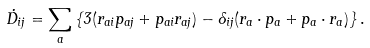Convert formula to latex. <formula><loc_0><loc_0><loc_500><loc_500>\dot { D } _ { i j } = \sum _ { a } \left \{ 3 ( r _ { a i } p _ { a j } + p _ { a i } r _ { a j } ) - \delta _ { i j } ( { r } _ { a } \cdot { p } _ { a } + { p } _ { a } \cdot { r } _ { a } ) \right \} .</formula> 